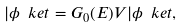Convert formula to latex. <formula><loc_0><loc_0><loc_500><loc_500>| \phi \ k e t = G _ { 0 } ( E ) V | \phi \ k e t ,</formula> 